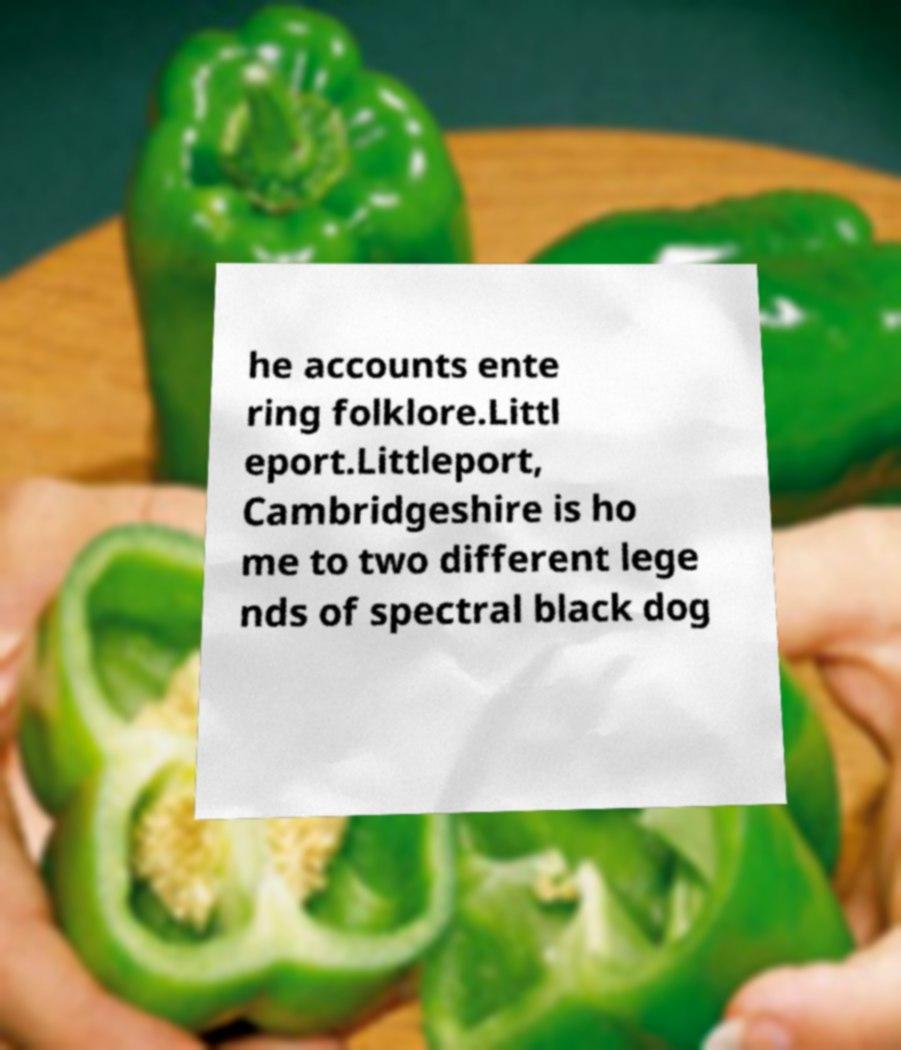There's text embedded in this image that I need extracted. Can you transcribe it verbatim? he accounts ente ring folklore.Littl eport.Littleport, Cambridgeshire is ho me to two different lege nds of spectral black dog 